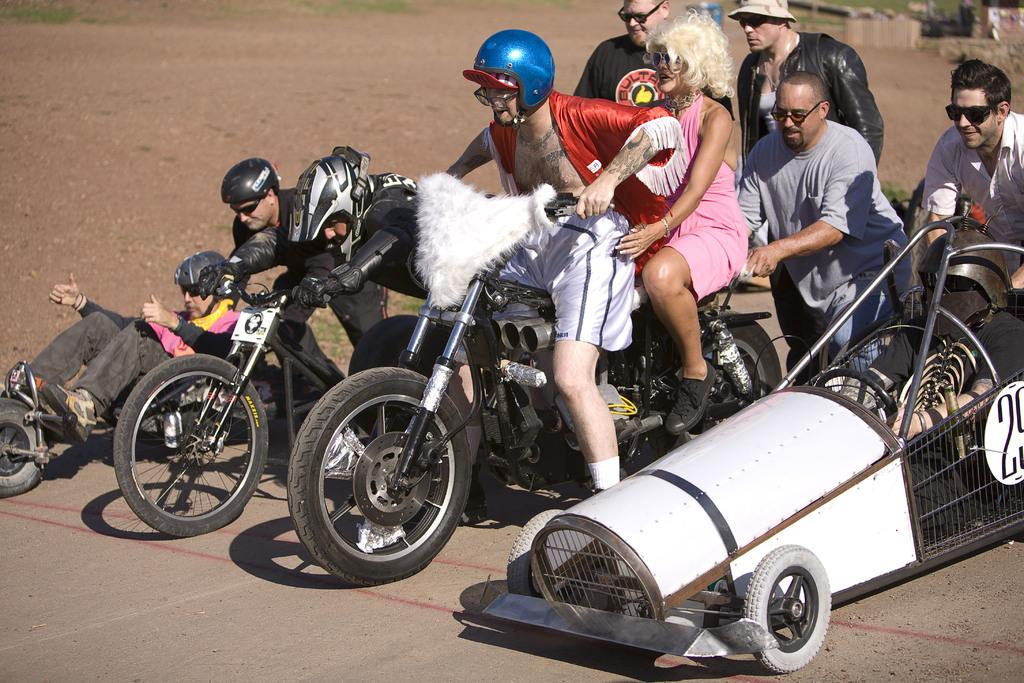What are the people in the image doing? The people in the image are sitting and standing. Can you describe a specific activity involving two people in the image? Two people are sitting on a motorcycle. What is another mode of transportation being used by someone in the image? One man is riding a bicycle. What type of grape is being used to treat the bicycle in the image? There is no grape present in the image, and the bicycle is not being treated. 